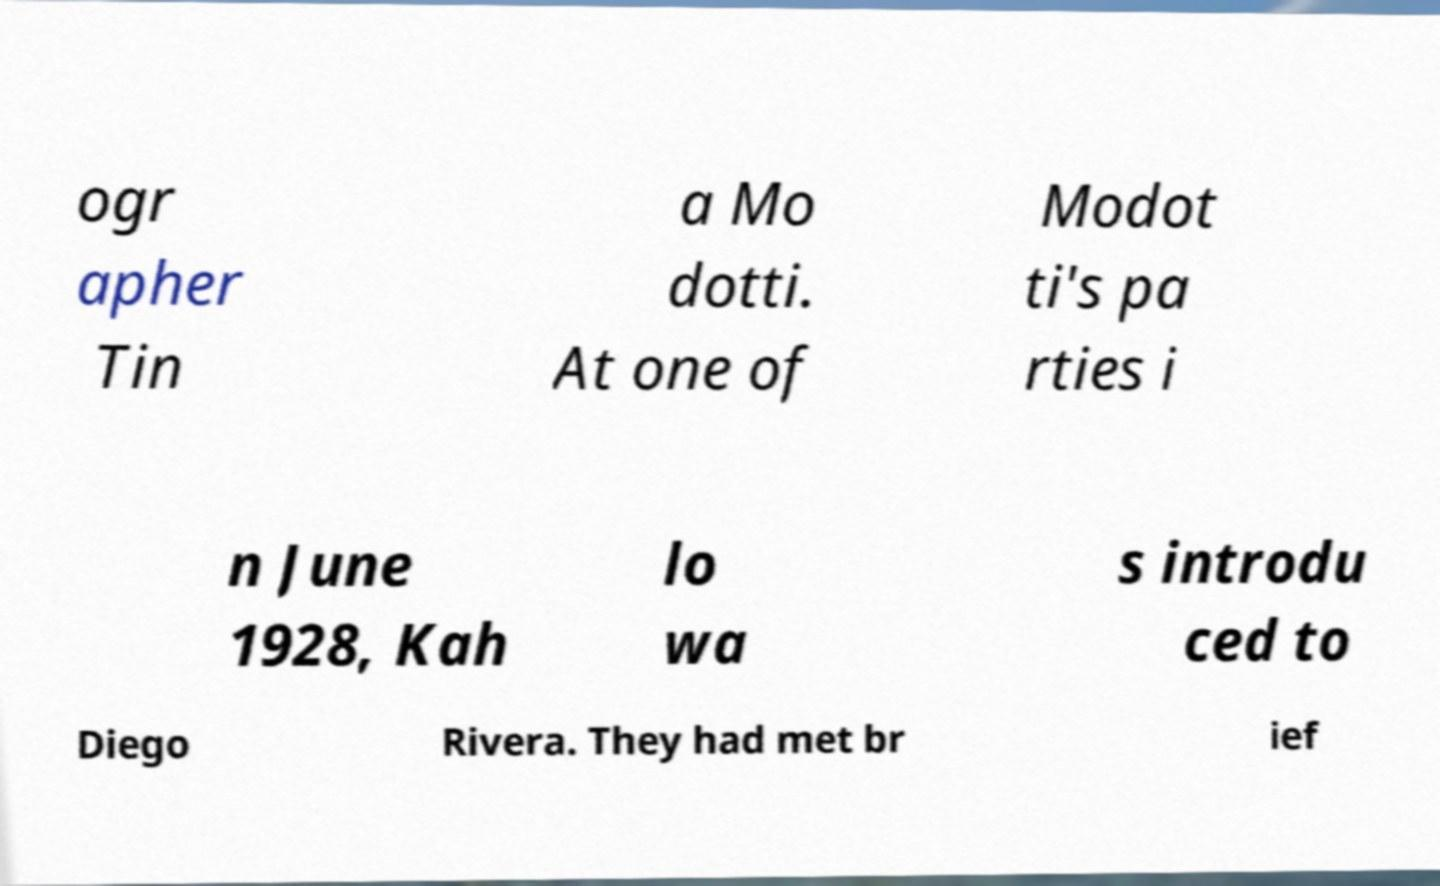Can you accurately transcribe the text from the provided image for me? ogr apher Tin a Mo dotti. At one of Modot ti's pa rties i n June 1928, Kah lo wa s introdu ced to Diego Rivera. They had met br ief 